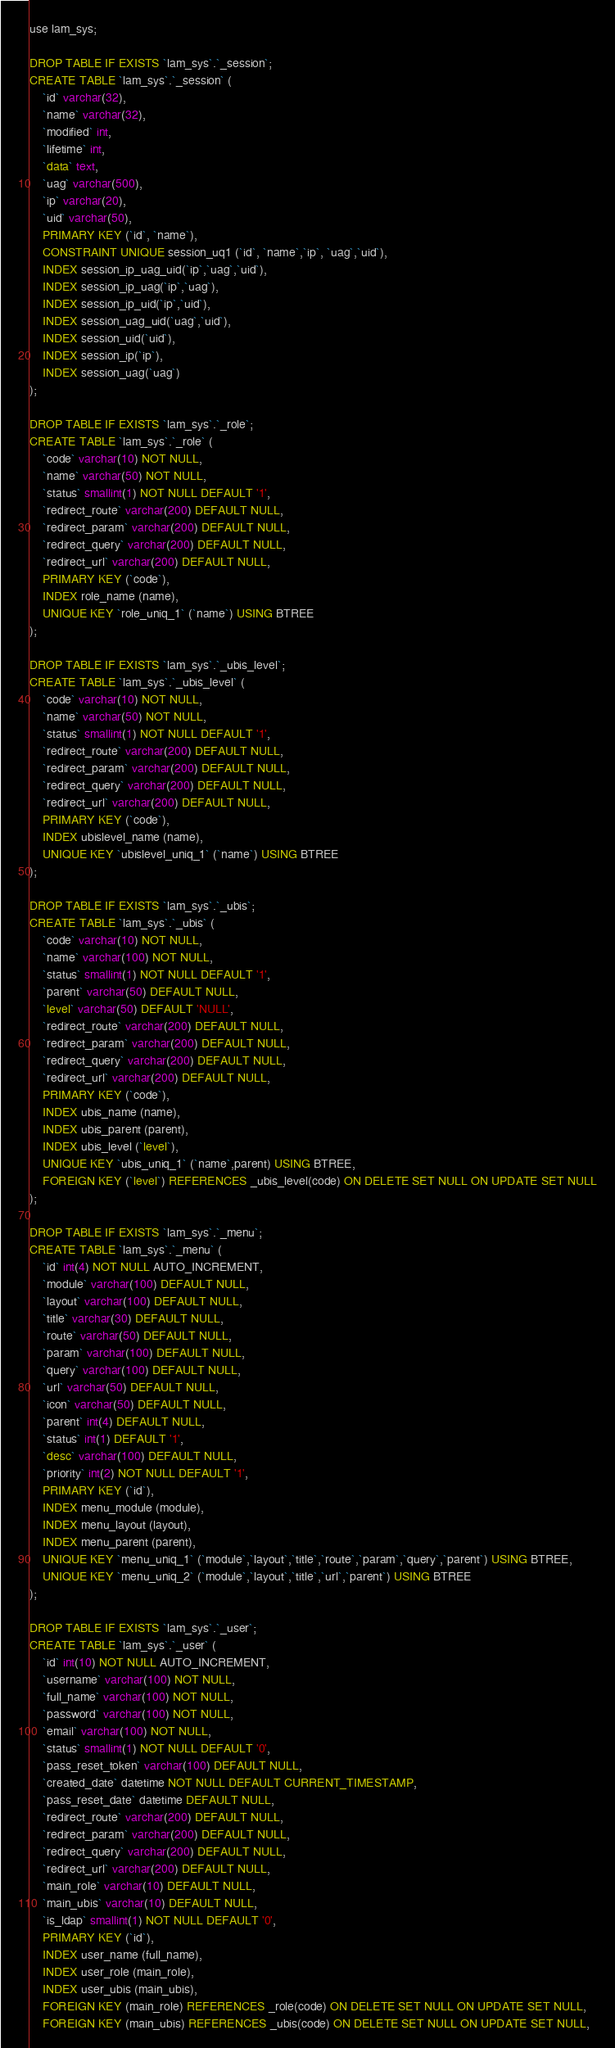<code> <loc_0><loc_0><loc_500><loc_500><_SQL_>use lam_sys;

DROP TABLE IF EXISTS `lam_sys`.`_session`;
CREATE TABLE `lam_sys`.`_session` (
    `id` varchar(32),
    `name` varchar(32),
    `modified` int,
    `lifetime` int,
    `data` text,
    `uag` varchar(500),
    `ip` varchar(20),
    `uid` varchar(50),
    PRIMARY KEY (`id`, `name`),
    CONSTRAINT UNIQUE session_uq1 (`id`, `name`,`ip`, `uag`,`uid`),
    INDEX session_ip_uag_uid(`ip`,`uag`,`uid`),
    INDEX session_ip_uag(`ip`,`uag`),
    INDEX session_ip_uid(`ip`,`uid`),
    INDEX session_uag_uid(`uag`,`uid`),
    INDEX session_uid(`uid`),
    INDEX session_ip(`ip`),
    INDEX session_uag(`uag`)
);

DROP TABLE IF EXISTS `lam_sys`.`_role`;
CREATE TABLE `lam_sys`.`_role` (
    `code` varchar(10) NOT NULL,
    `name` varchar(50) NOT NULL,
    `status` smallint(1) NOT NULL DEFAULT '1',
    `redirect_route` varchar(200) DEFAULT NULL,
    `redirect_param` varchar(200) DEFAULT NULL,
    `redirect_query` varchar(200) DEFAULT NULL,
    `redirect_url` varchar(200) DEFAULT NULL,
    PRIMARY KEY (`code`),
    INDEX role_name (name),
    UNIQUE KEY `role_uniq_1` (`name`) USING BTREE
);

DROP TABLE IF EXISTS `lam_sys`.`_ubis_level`;
CREATE TABLE `lam_sys`.`_ubis_level` (
    `code` varchar(10) NOT NULL,
    `name` varchar(50) NOT NULL,
    `status` smallint(1) NOT NULL DEFAULT '1',
    `redirect_route` varchar(200) DEFAULT NULL,
    `redirect_param` varchar(200) DEFAULT NULL,
    `redirect_query` varchar(200) DEFAULT NULL,
    `redirect_url` varchar(200) DEFAULT NULL,
    PRIMARY KEY (`code`),
    INDEX ubislevel_name (name),
    UNIQUE KEY `ubislevel_uniq_1` (`name`) USING BTREE
);

DROP TABLE IF EXISTS `lam_sys`.`_ubis`;
CREATE TABLE `lam_sys`.`_ubis` (
    `code` varchar(10) NOT NULL,
    `name` varchar(100) NOT NULL,
    `status` smallint(1) NOT NULL DEFAULT '1',
    `parent` varchar(50) DEFAULT NULL,
    `level` varchar(50) DEFAULT 'NULL',
    `redirect_route` varchar(200) DEFAULT NULL,
    `redirect_param` varchar(200) DEFAULT NULL,
    `redirect_query` varchar(200) DEFAULT NULL,
    `redirect_url` varchar(200) DEFAULT NULL,
    PRIMARY KEY (`code`),
    INDEX ubis_name (name),
    INDEX ubis_parent (parent),
    INDEX ubis_level (`level`),
    UNIQUE KEY `ubis_uniq_1` (`name`,parent) USING BTREE,
    FOREIGN KEY (`level`) REFERENCES _ubis_level(code) ON DELETE SET NULL ON UPDATE SET NULL
);

DROP TABLE IF EXISTS `lam_sys`.`_menu`;
CREATE TABLE `lam_sys`.`_menu` (
    `id` int(4) NOT NULL AUTO_INCREMENT,
    `module` varchar(100) DEFAULT NULL,
    `layout` varchar(100) DEFAULT NULL,
    `title` varchar(30) DEFAULT NULL,
    `route` varchar(50) DEFAULT NULL,
    `param` varchar(100) DEFAULT NULL,
    `query` varchar(100) DEFAULT NULL,
    `url` varchar(50) DEFAULT NULL,
    `icon` varchar(50) DEFAULT NULL,
    `parent` int(4) DEFAULT NULL,
    `status` int(1) DEFAULT '1',
    `desc` varchar(100) DEFAULT NULL,
    `priority` int(2) NOT NULL DEFAULT '1',
    PRIMARY KEY (`id`),
    INDEX menu_module (module),
    INDEX menu_layout (layout),
    INDEX menu_parent (parent),
    UNIQUE KEY `menu_uniq_1` (`module`,`layout`,`title`,`route`,`param`,`query`,`parent`) USING BTREE,
    UNIQUE KEY `menu_uniq_2` (`module`,`layout`,`title`,`url`,`parent`) USING BTREE
);

DROP TABLE IF EXISTS `lam_sys`.`_user`;
CREATE TABLE `lam_sys`.`_user` (
    `id` int(10) NOT NULL AUTO_INCREMENT,
    `username` varchar(100) NOT NULL,
    `full_name` varchar(100) NOT NULL,
    `password` varchar(100) NOT NULL,
    `email` varchar(100) NOT NULL,
    `status` smallint(1) NOT NULL DEFAULT '0',
    `pass_reset_token` varchar(100) DEFAULT NULL,
    `created_date` datetime NOT NULL DEFAULT CURRENT_TIMESTAMP,
    `pass_reset_date` datetime DEFAULT NULL,
    `redirect_route` varchar(200) DEFAULT NULL,
    `redirect_param` varchar(200) DEFAULT NULL,
    `redirect_query` varchar(200) DEFAULT NULL,
    `redirect_url` varchar(200) DEFAULT NULL,
    `main_role` varchar(10) DEFAULT NULL,
    `main_ubis` varchar(10) DEFAULT NULL,
    `is_ldap` smallint(1) NOT NULL DEFAULT '0',
    PRIMARY KEY (`id`),
    INDEX user_name (full_name),
    INDEX user_role (main_role),
    INDEX user_ubis (main_ubis),
    FOREIGN KEY (main_role) REFERENCES _role(code) ON DELETE SET NULL ON UPDATE SET NULL,
    FOREIGN KEY (main_ubis) REFERENCES _ubis(code) ON DELETE SET NULL ON UPDATE SET NULL,</code> 